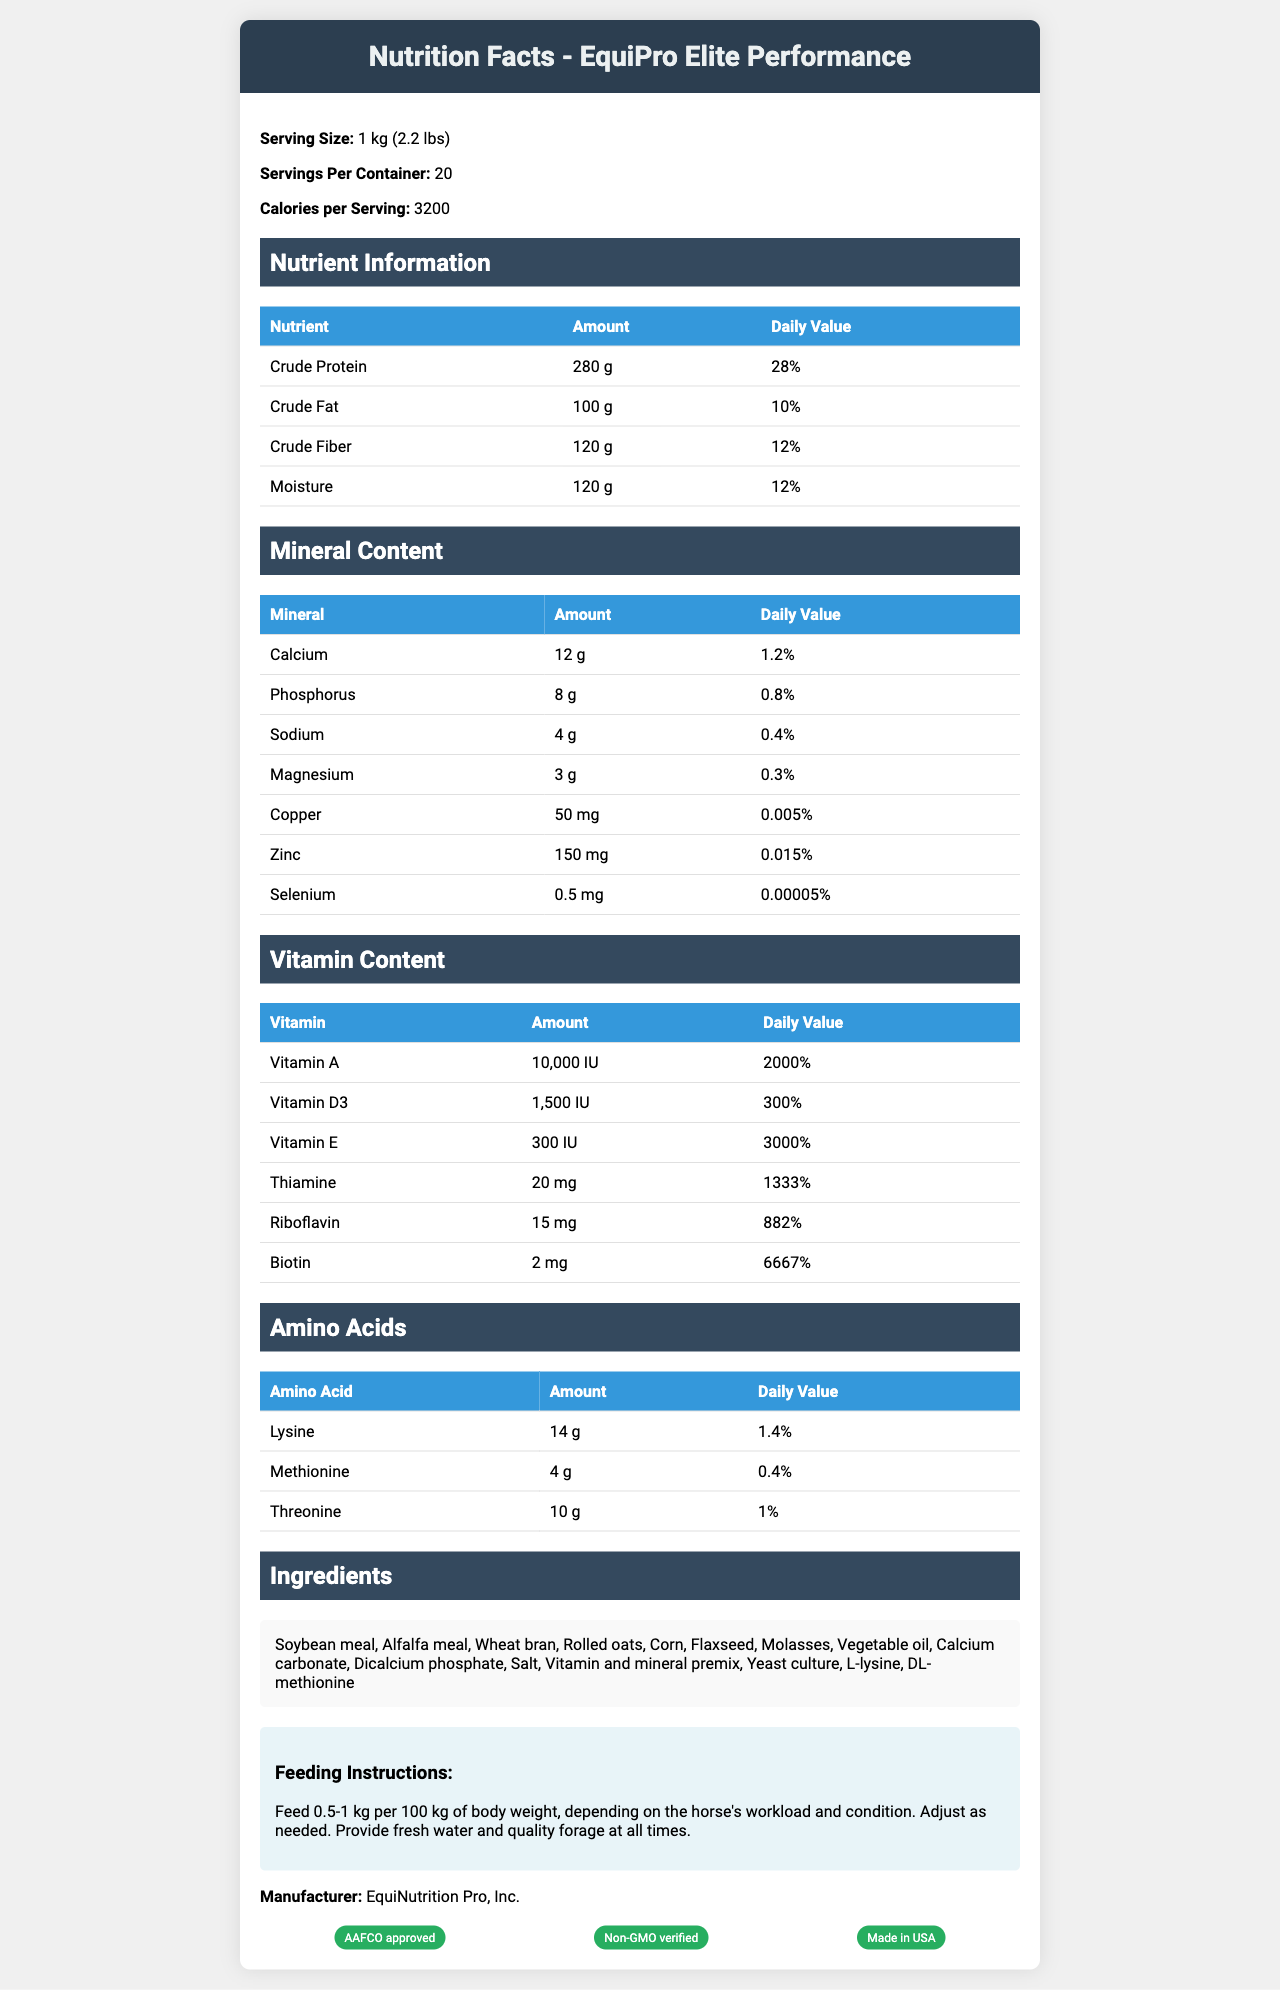what is the serving size of EquiPro Elite Performance? The serving size is listed as "1 kg (2.2 lbs)" on the document.
Answer: 1 kg (2.2 lbs) how many servings are in one container? The document states there are 20 servings per container.
Answer: 20 how many calories are in each serving? The calories per serving are listed as 3200 in the document.
Answer: 3200 what is the amount of crude protein per serving? Crude protein amount per serving is listed as 280 g.
Answer: 280 g what is the percentage of daily value for crude fat? Crude fat has a daily value percentage of 10%.
Answer: 10% what are the feeding instructions? The feeding instructions are provided in the document under the "Feeding Instructions" section.
Answer: Feed 0.5-1 kg per 100 kg of body weight, depending on the horse's workload and condition. Adjust as needed. Provide fresh water and quality forage at all times. which vitamin has the highest daily value percentage? A. Vitamin A B. Vitamin D3 C. Vitamin E The document states Vitamin E has a daily value percentage of 3000%, which is the highest among the listed vitamins.
Answer: C. Vitamin E which ingredient is not included in EquiPro Elite Performance? 1. Soybean meal 2. Rice bran 3. Flaxseed 4. Alfalfa meal The listed ingredients include Soybean meal, Flaxseed, and Alfalfa meal, but not Rice bran.
Answer: 2. Rice bran is EquiPro Elite Performance AAFCO approved? The certification section lists "AAFCO approved" as one of the certifications.
Answer: Yes does the document specify the shelf life of the product? The document does not mention the shelf life of EquiPro Elite Performance.
Answer: Not enough information summarize the main features of the EquiPro Elite Performance horse feed. The document provides detailed nutrient, mineral, vitamin, and amino acid content of the product. It lists ingredients, feeding instructions, and certifications, emphasizing the high protein content and balanced formulation for optimal horse health.
Answer: EquiPro Elite Performance is a premium horse feed with a high protein content (28% crude protein) and balanced minerals. Each serving is 1 kg and provides 3200 calories. The feed includes various essential vitamins, minerals, and amino acids, and is made from ingredients like soybean meal, alfalfa meal, wheat bran, and more. It has feeding instructions based on horse body weight and workload. The product is AAFCO approved, Non-GMO verified, and made in the USA. 